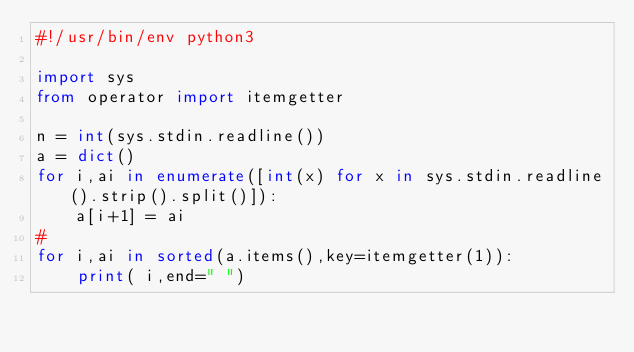Convert code to text. <code><loc_0><loc_0><loc_500><loc_500><_Python_>#!/usr/bin/env python3

import sys
from operator import itemgetter

n = int(sys.stdin.readline())
a = dict()
for i,ai in enumerate([int(x) for x in sys.stdin.readline().strip().split()]):
    a[i+1] = ai
#
for i,ai in sorted(a.items(),key=itemgetter(1)):
    print( i,end=" ")
</code> 